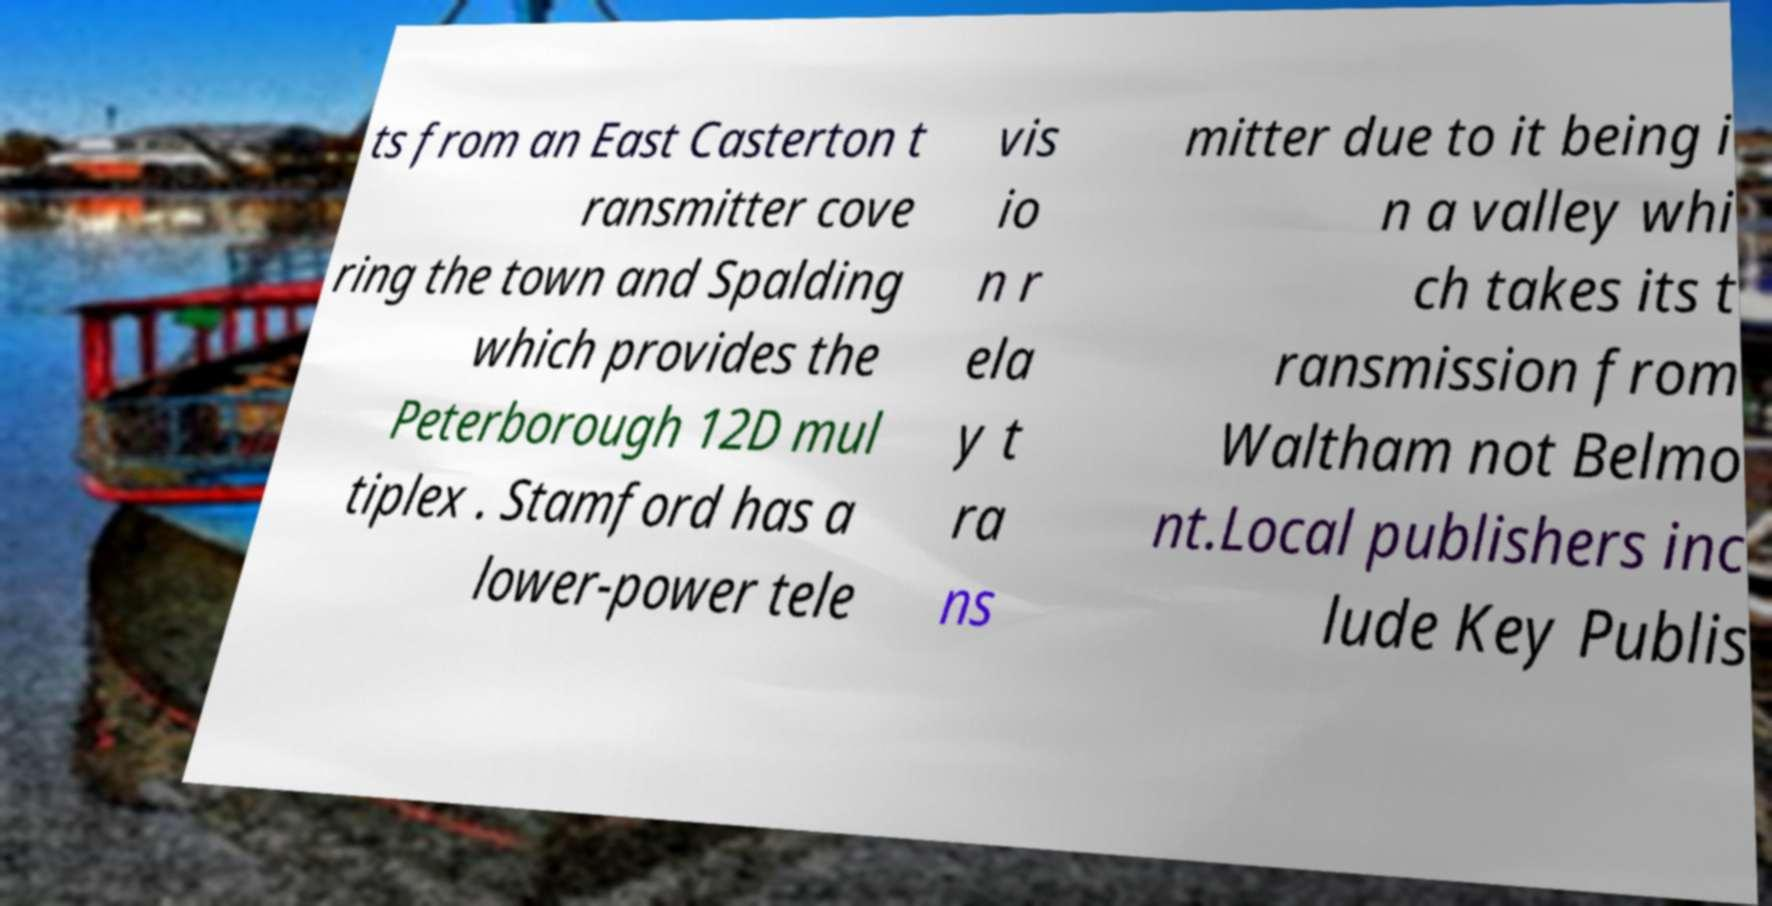There's text embedded in this image that I need extracted. Can you transcribe it verbatim? ts from an East Casterton t ransmitter cove ring the town and Spalding which provides the Peterborough 12D mul tiplex . Stamford has a lower-power tele vis io n r ela y t ra ns mitter due to it being i n a valley whi ch takes its t ransmission from Waltham not Belmo nt.Local publishers inc lude Key Publis 